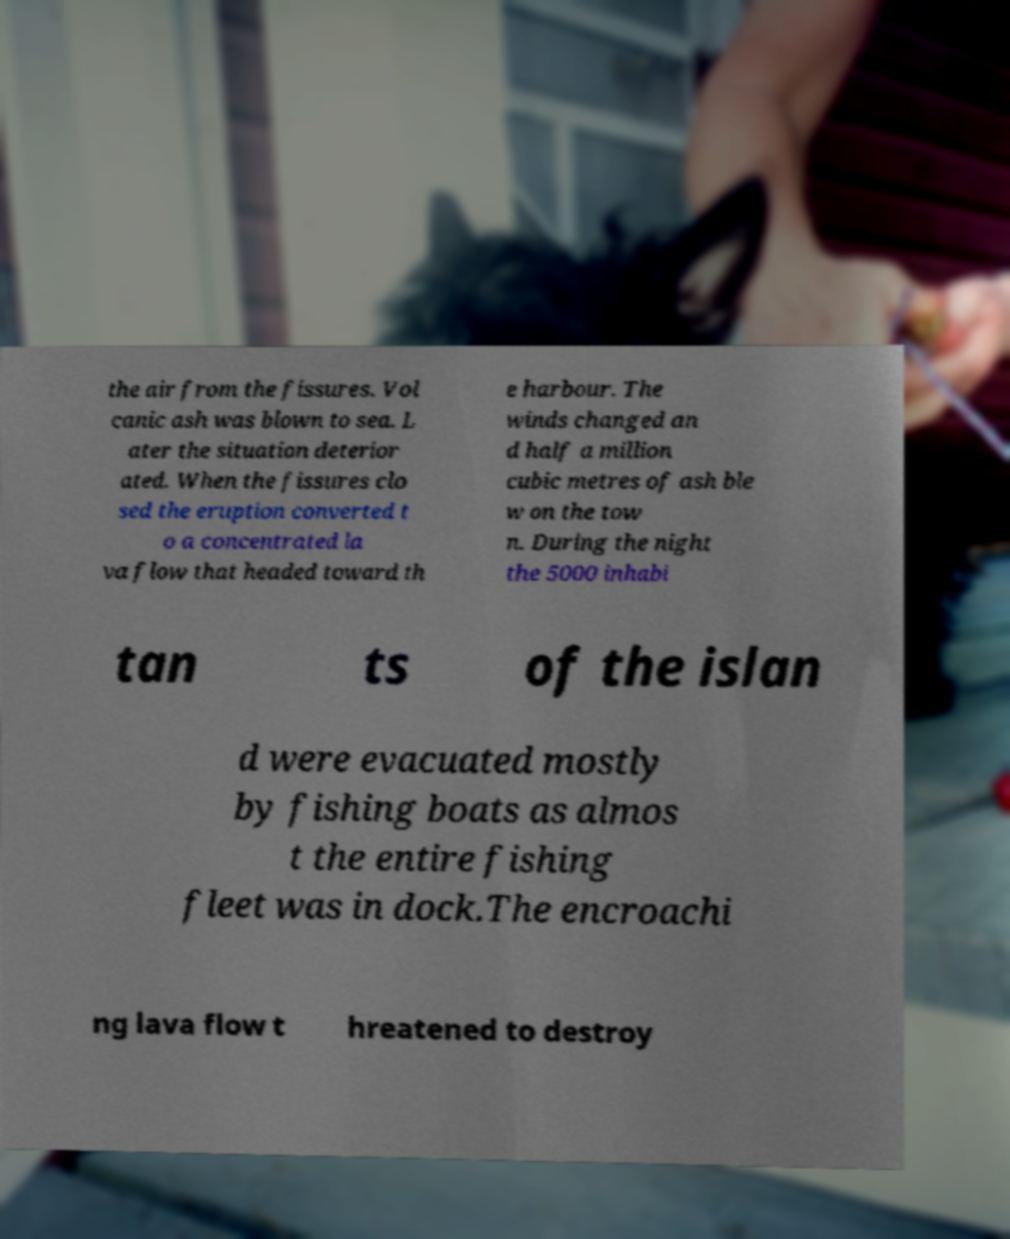Could you assist in decoding the text presented in this image and type it out clearly? the air from the fissures. Vol canic ash was blown to sea. L ater the situation deterior ated. When the fissures clo sed the eruption converted t o a concentrated la va flow that headed toward th e harbour. The winds changed an d half a million cubic metres of ash ble w on the tow n. During the night the 5000 inhabi tan ts of the islan d were evacuated mostly by fishing boats as almos t the entire fishing fleet was in dock.The encroachi ng lava flow t hreatened to destroy 